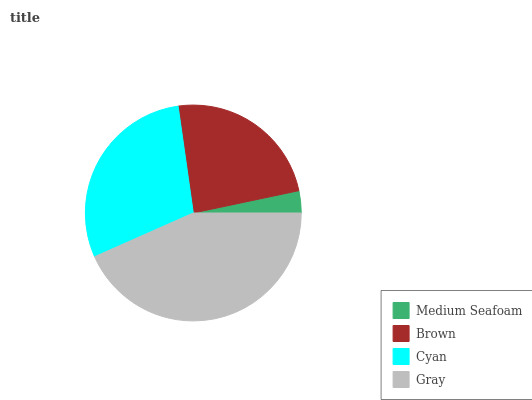Is Medium Seafoam the minimum?
Answer yes or no. Yes. Is Gray the maximum?
Answer yes or no. Yes. Is Brown the minimum?
Answer yes or no. No. Is Brown the maximum?
Answer yes or no. No. Is Brown greater than Medium Seafoam?
Answer yes or no. Yes. Is Medium Seafoam less than Brown?
Answer yes or no. Yes. Is Medium Seafoam greater than Brown?
Answer yes or no. No. Is Brown less than Medium Seafoam?
Answer yes or no. No. Is Cyan the high median?
Answer yes or no. Yes. Is Brown the low median?
Answer yes or no. Yes. Is Gray the high median?
Answer yes or no. No. Is Gray the low median?
Answer yes or no. No. 